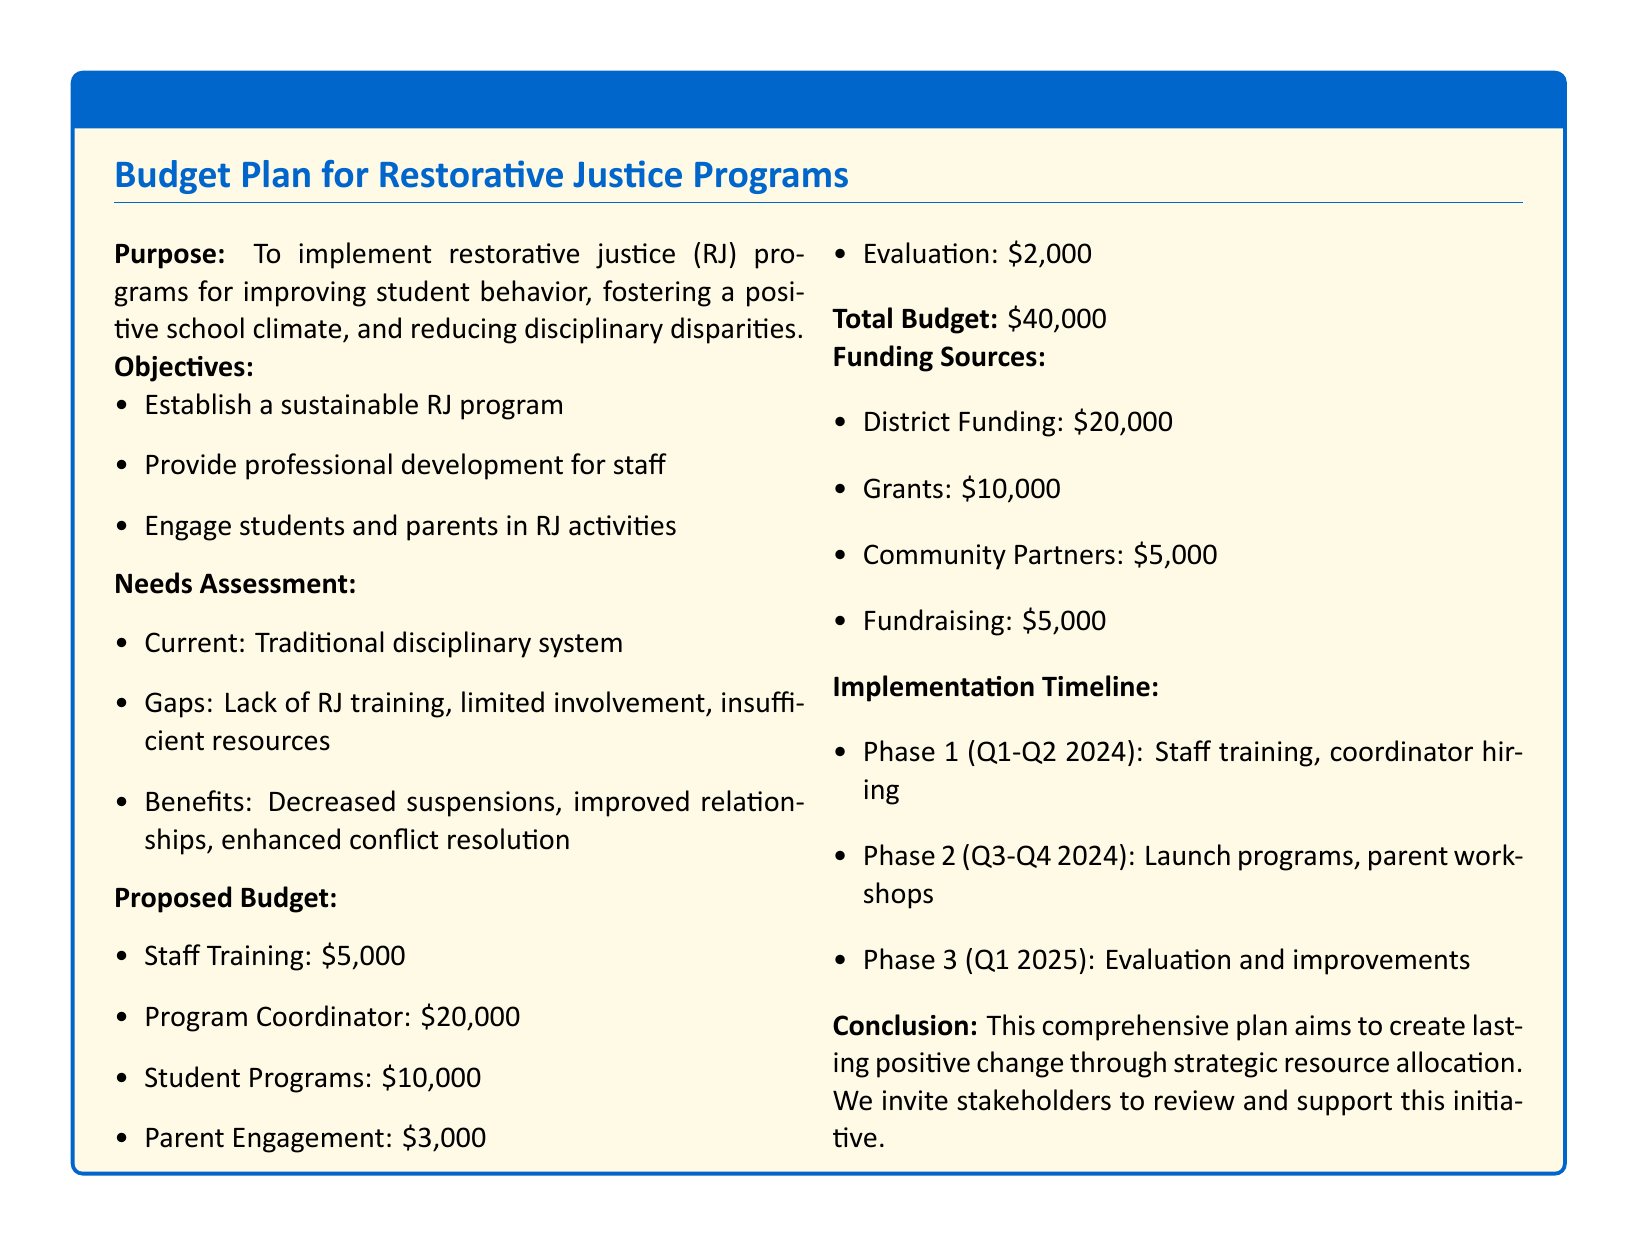What is the purpose of the proposal? The purpose is to implement restorative justice programs for improving student behavior, fostering a positive school climate, and reducing disciplinary disparities.
Answer: To implement restorative justice programs What is the total budget requested? The document states the total budget for the restorative justice programs is clearly specified.
Answer: $40,000 How much is allocated for staff training? The budget section lists specific allocations for various items, including staff training.
Answer: $5,000 What is the main gap identified in the needs assessment? The needs assessment highlights specific gaps in the current disciplinary system that need addressing.
Answer: Lack of RJ training What is the evaluation budget? By reviewing the proposed budget section, one can find the allocation for evaluation purposes.
Answer: $2,000 What phase includes parent workshops? The implementation timeline specifies activities organized across different phases, indicating when each will occur.
Answer: Phase 2 (Q3-Q4 2024) What funding source contributes the most? The funding sources are broken down, indicating which contributes the largest amount to the budget.
Answer: District Funding: $20,000 How much is budgeted for student programs? The proposed budget outlines the amount dedicated to student programs.
Answer: $10,000 What is the expected outcome of the program as stated in the benefits? The document outlines several expected benefits that come from the implementation of the program.
Answer: Improved relationships 